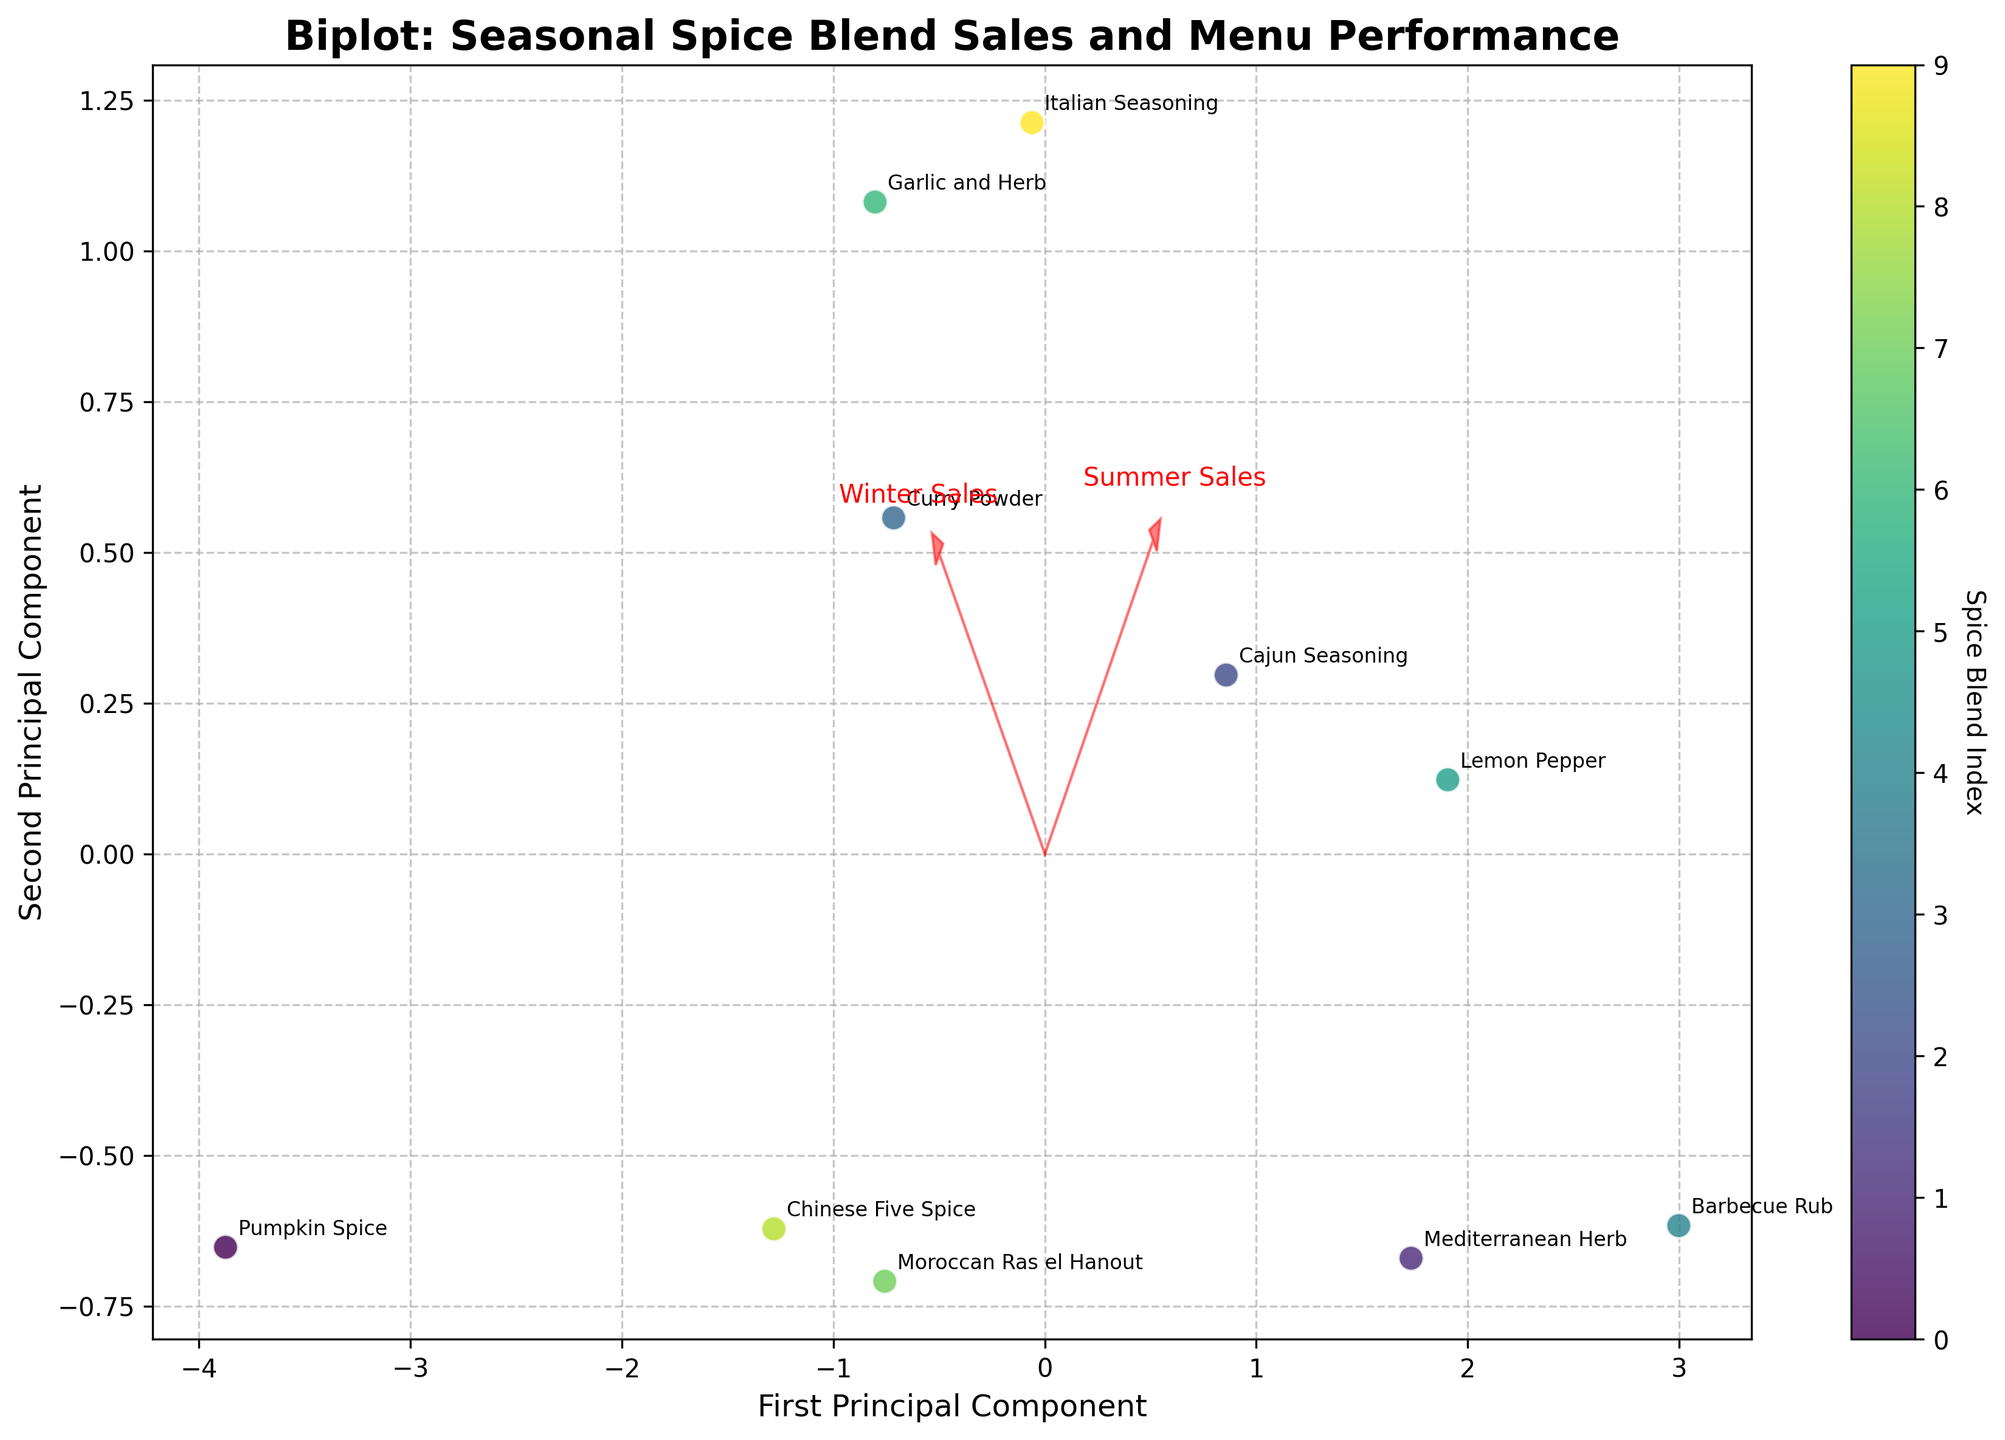What is the title of the figure? The title of the figure is usually displayed at the top and provides a brief description of what the figure is about.
Answer: Biplot: Seasonal Spice Blend Sales and Menu Performance How many spice blends are represented in the plot? Count the number of different spice blends labeled on the plot.
Answer: 10 Which seasonal performance vectors are closest together in the plot? Observe the direction and closeness of the vectors named "Winter Menu" and "Summer Menu" to see which are closest.
Answer: Winter Menu and Summer Menu Which spice blend has the highest first principal component value? Look at the plotted points along the x-axis (first principal component) and identify the one with the highest value.
Answer: Pumpkin Spice Which spice blend has the lowest second principal component value? Look at the plotted points along the y-axis (second principal component) and identify the one with the lowest value.
Answer: Mediterranean Herb Which two spice blends have the most similar performance in the winter season? Compare the points labeled with spice blends to see which ones are closest along the vectors corresponding to winter sales or performance.
Answer: Curry Powder and Italian Seasoning How do winter sales generally compare to summer sales across the blends? Look at the directions and lengths of the vectors for winter sales and summer sales to infer how they compare across all points.
Answer: Winter sales are generally lower than summer sales Which spice blend has a higher performance in winter compared to summer? Look for the spice blend that is positioned closer to the Winter Menu and away from the Summer Menu vector.
Answer: Pumpkin Spice Is winter menu performance more correlated with winter sales or summer sales? Check the orientation and direction of the Winter Menu vector in relation to the Winter Sales and Summer Sales vectors.
Answer: Winter sales What trend can we infer about spice blends that perform well in the summer? Identify the spice blends that are positioned closely to the Summer Menu vector and observe how they perform in other areas.
Answer: They generally have higher summer sales 